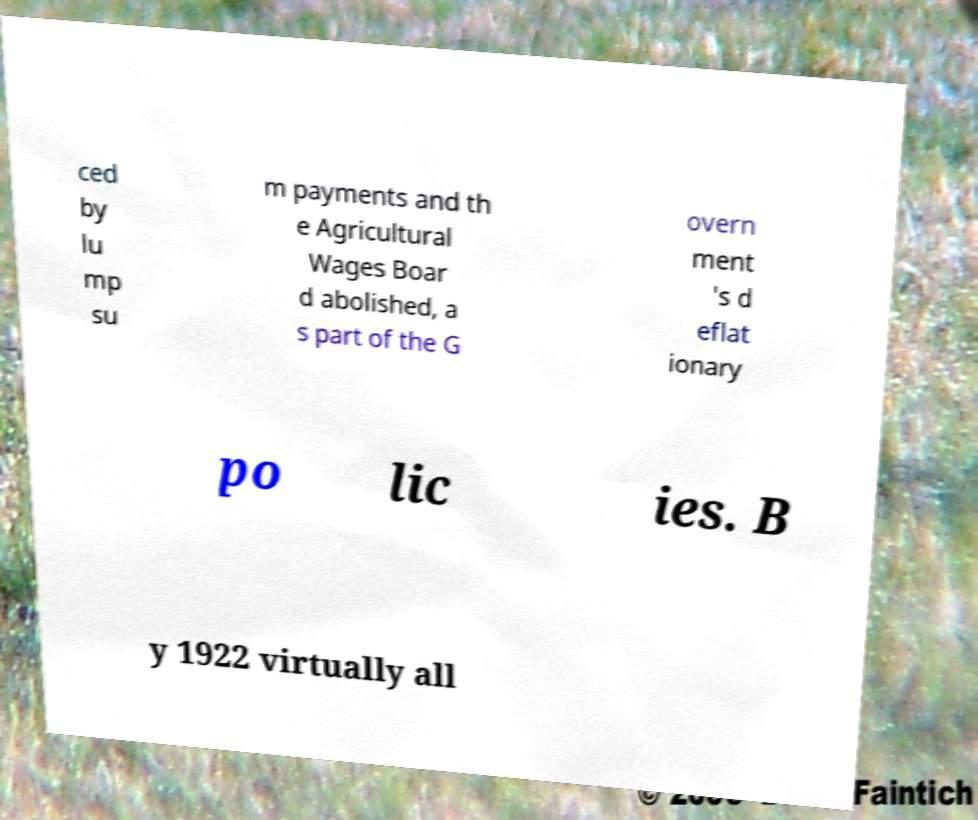Please identify and transcribe the text found in this image. ced by lu mp su m payments and th e Agricultural Wages Boar d abolished, a s part of the G overn ment 's d eflat ionary po lic ies. B y 1922 virtually all 